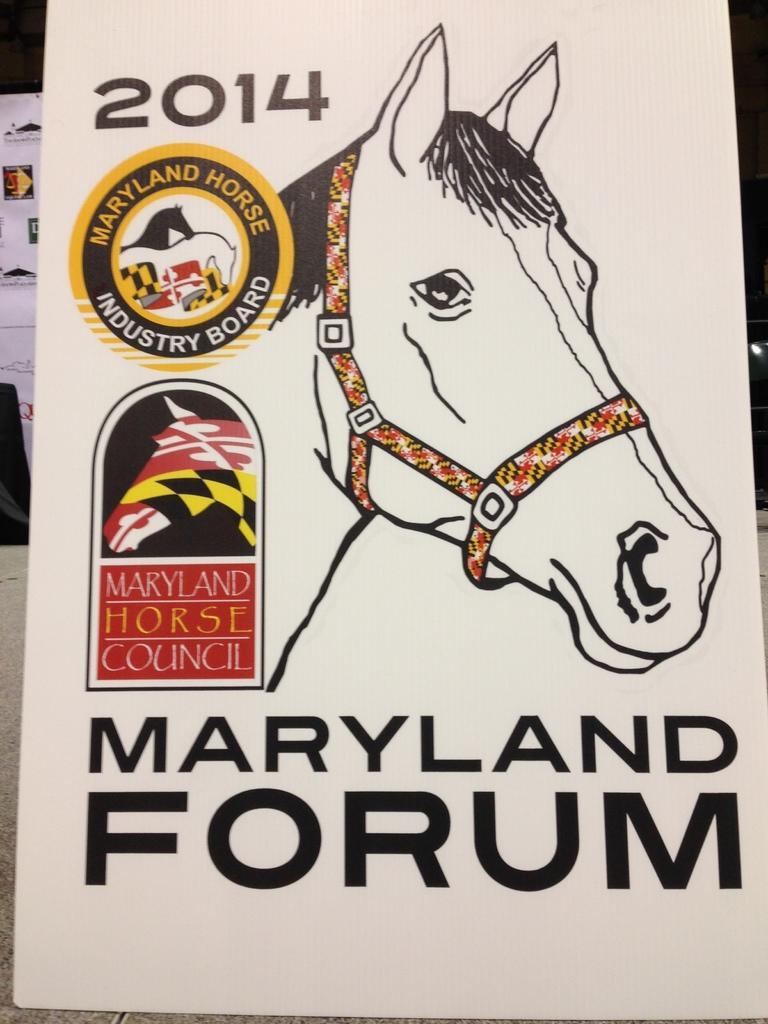Please provide a concise description of this image. This is a poster. On this poster we can see picture of a horse, and a logo. There is text written on it. 